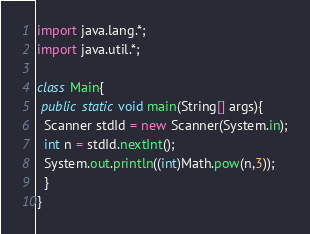Convert code to text. <code><loc_0><loc_0><loc_500><loc_500><_Java_>import java.lang.*;
import java.util.*;

class Main{
 public static void main(String[] args){
  Scanner stdId = new Scanner(System.in);
  int n = stdId.nextInt();
  System.out.println((int)Math.pow(n,3));
  }
}</code> 